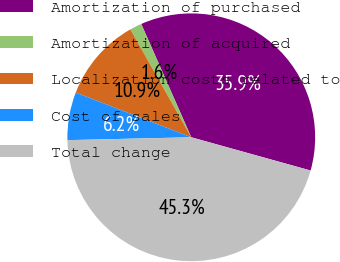Convert chart. <chart><loc_0><loc_0><loc_500><loc_500><pie_chart><fcel>Amortization of purchased<fcel>Amortization of acquired<fcel>Localization costs related to<fcel>Cost of sales<fcel>Total change<nl><fcel>35.94%<fcel>1.56%<fcel>10.94%<fcel>6.25%<fcel>45.31%<nl></chart> 